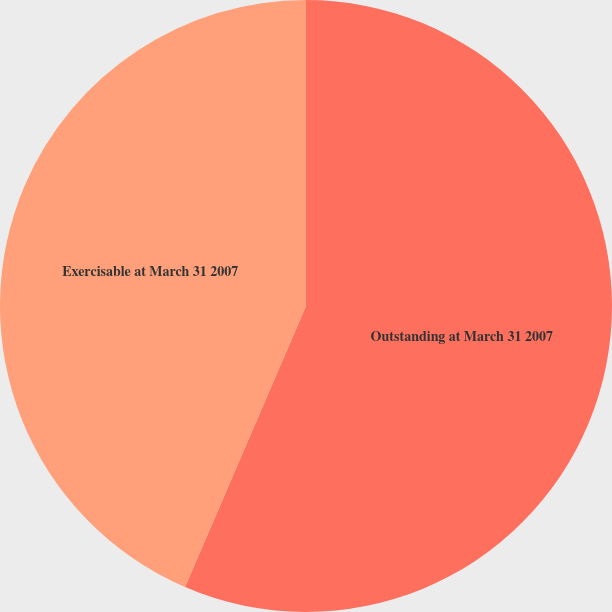Convert chart to OTSL. <chart><loc_0><loc_0><loc_500><loc_500><pie_chart><fcel>Outstanding at March 31 2007<fcel>Exercisable at March 31 2007<nl><fcel>56.47%<fcel>43.53%<nl></chart> 